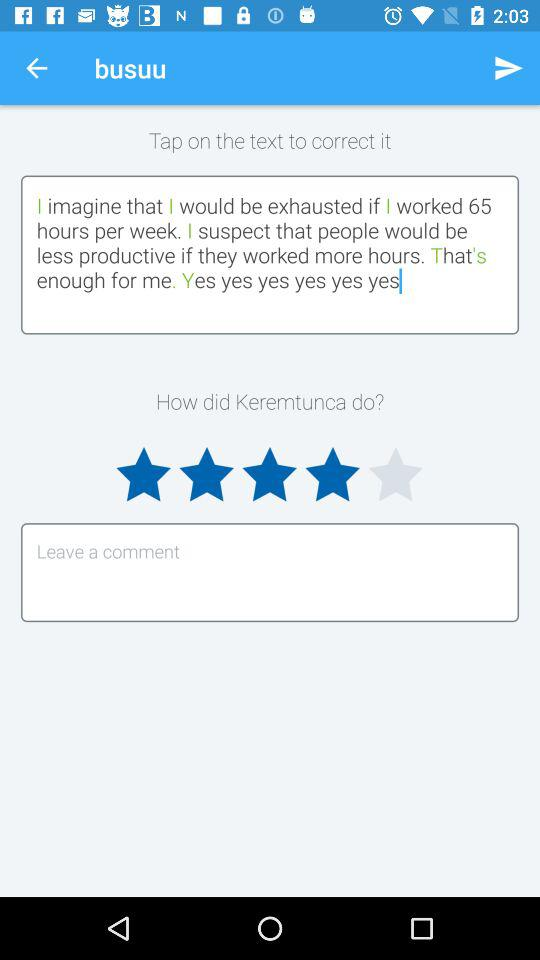How many stars did Keremtunca get? Keremtunca got 4 stars. 